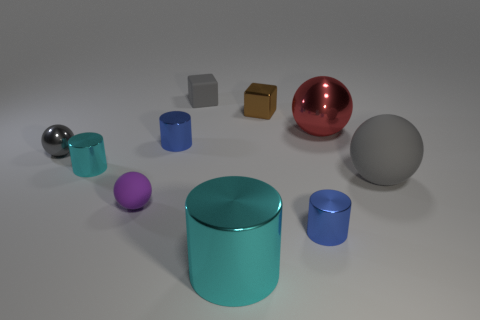Is the number of large shiny objects less than the number of red metal objects?
Keep it short and to the point. No. Do the small purple thing right of the small gray sphere and the large gray thing have the same shape?
Your answer should be compact. Yes. Are there any matte spheres?
Provide a short and direct response. Yes. The rubber ball that is in front of the large rubber object in front of the cyan object that is behind the big cyan cylinder is what color?
Ensure brevity in your answer.  Purple. Are there the same number of tiny objects that are on the left side of the tiny shiny sphere and small brown shiny cubes that are in front of the purple object?
Ensure brevity in your answer.  Yes. There is a cyan shiny object that is the same size as the purple matte object; what shape is it?
Your response must be concise. Cylinder. Is there a tiny shiny sphere that has the same color as the large matte ball?
Your answer should be compact. Yes. The rubber object that is to the right of the brown object has what shape?
Ensure brevity in your answer.  Sphere. The tiny matte cube is what color?
Ensure brevity in your answer.  Gray. What color is the cube that is made of the same material as the big red thing?
Give a very brief answer. Brown. 